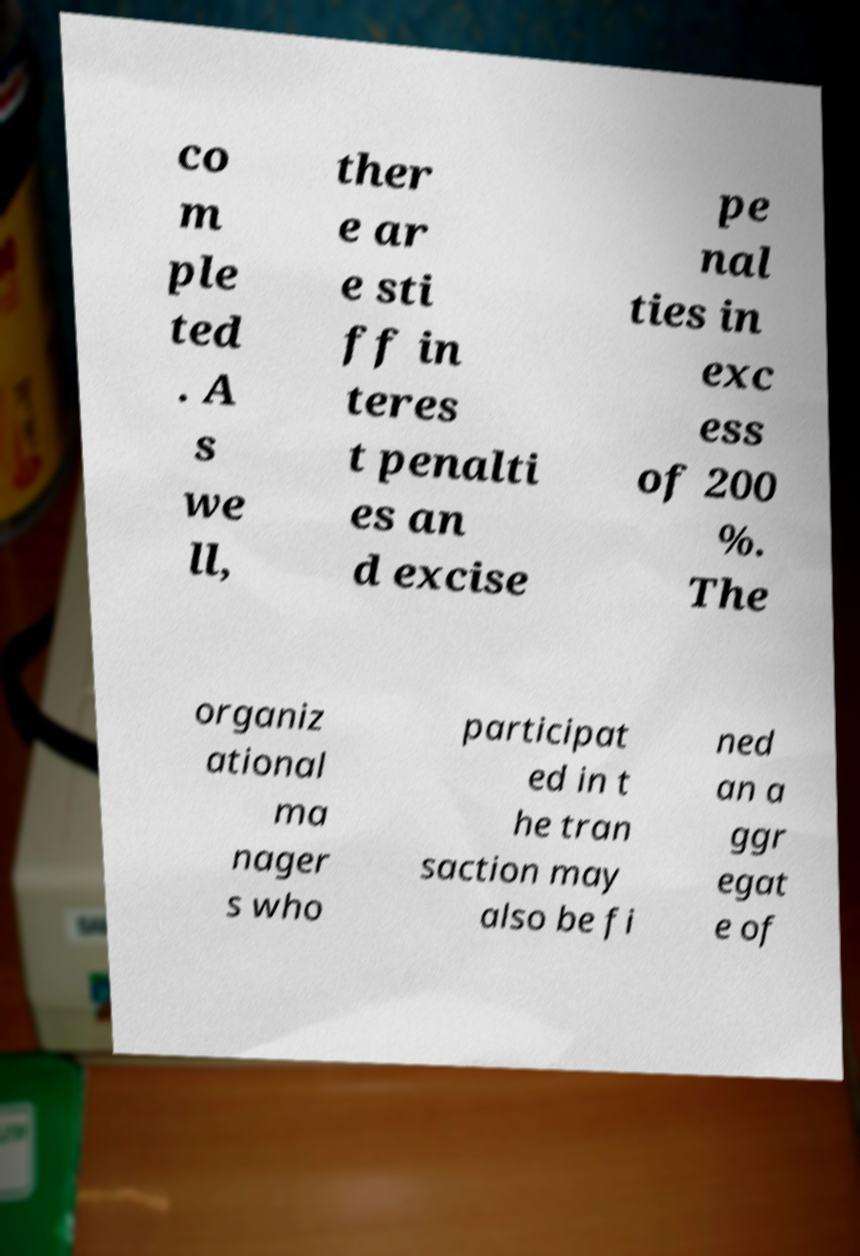Can you accurately transcribe the text from the provided image for me? co m ple ted . A s we ll, ther e ar e sti ff in teres t penalti es an d excise pe nal ties in exc ess of 200 %. The organiz ational ma nager s who participat ed in t he tran saction may also be fi ned an a ggr egat e of 